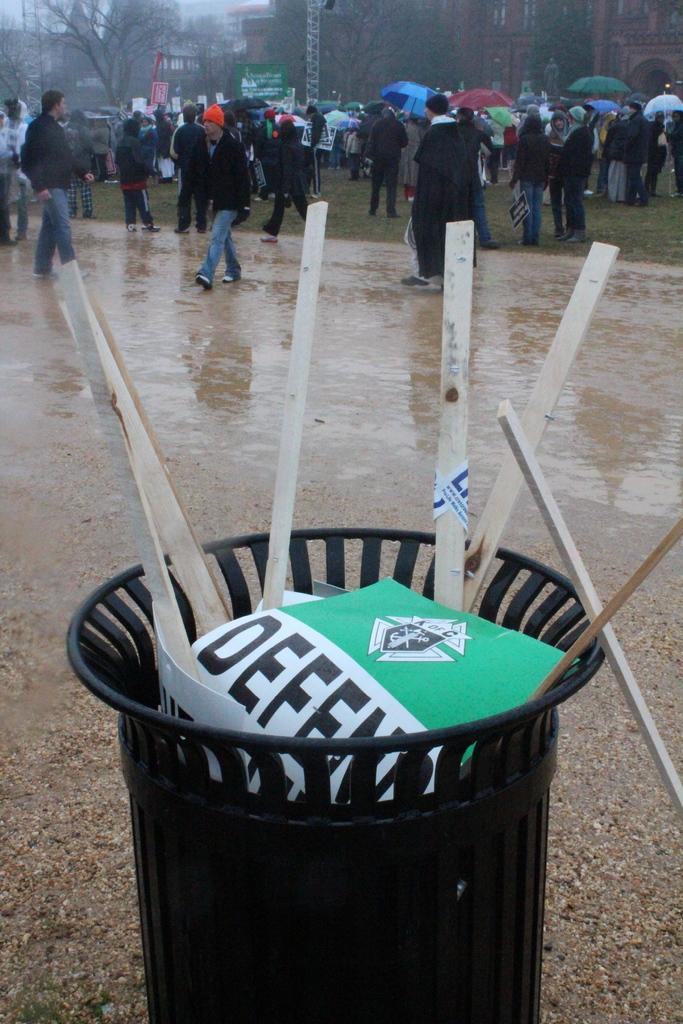<image>
Offer a succinct explanation of the picture presented. Defense sign in a trash can at the top with people walking around. 